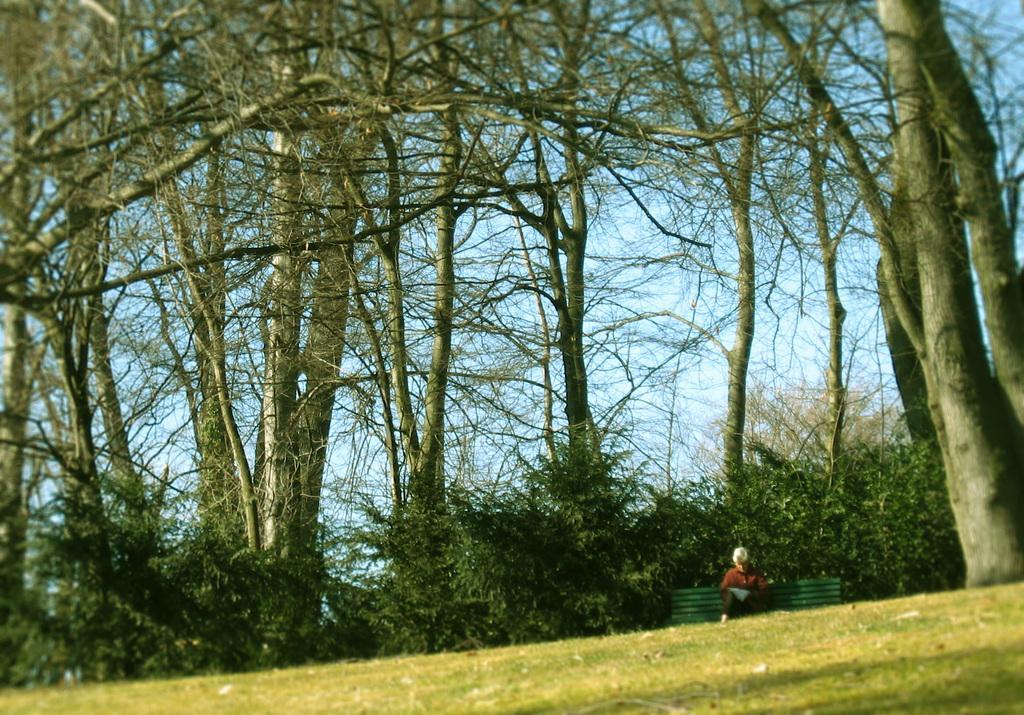Can you describe this image briefly? This picture might be taken from outside of the city and it is sunny. In this image, on the right side, we can see a person sitting on the bench and some trees. In the background, there are some trees. On top there is a sky, at the bottom there is a grass. 